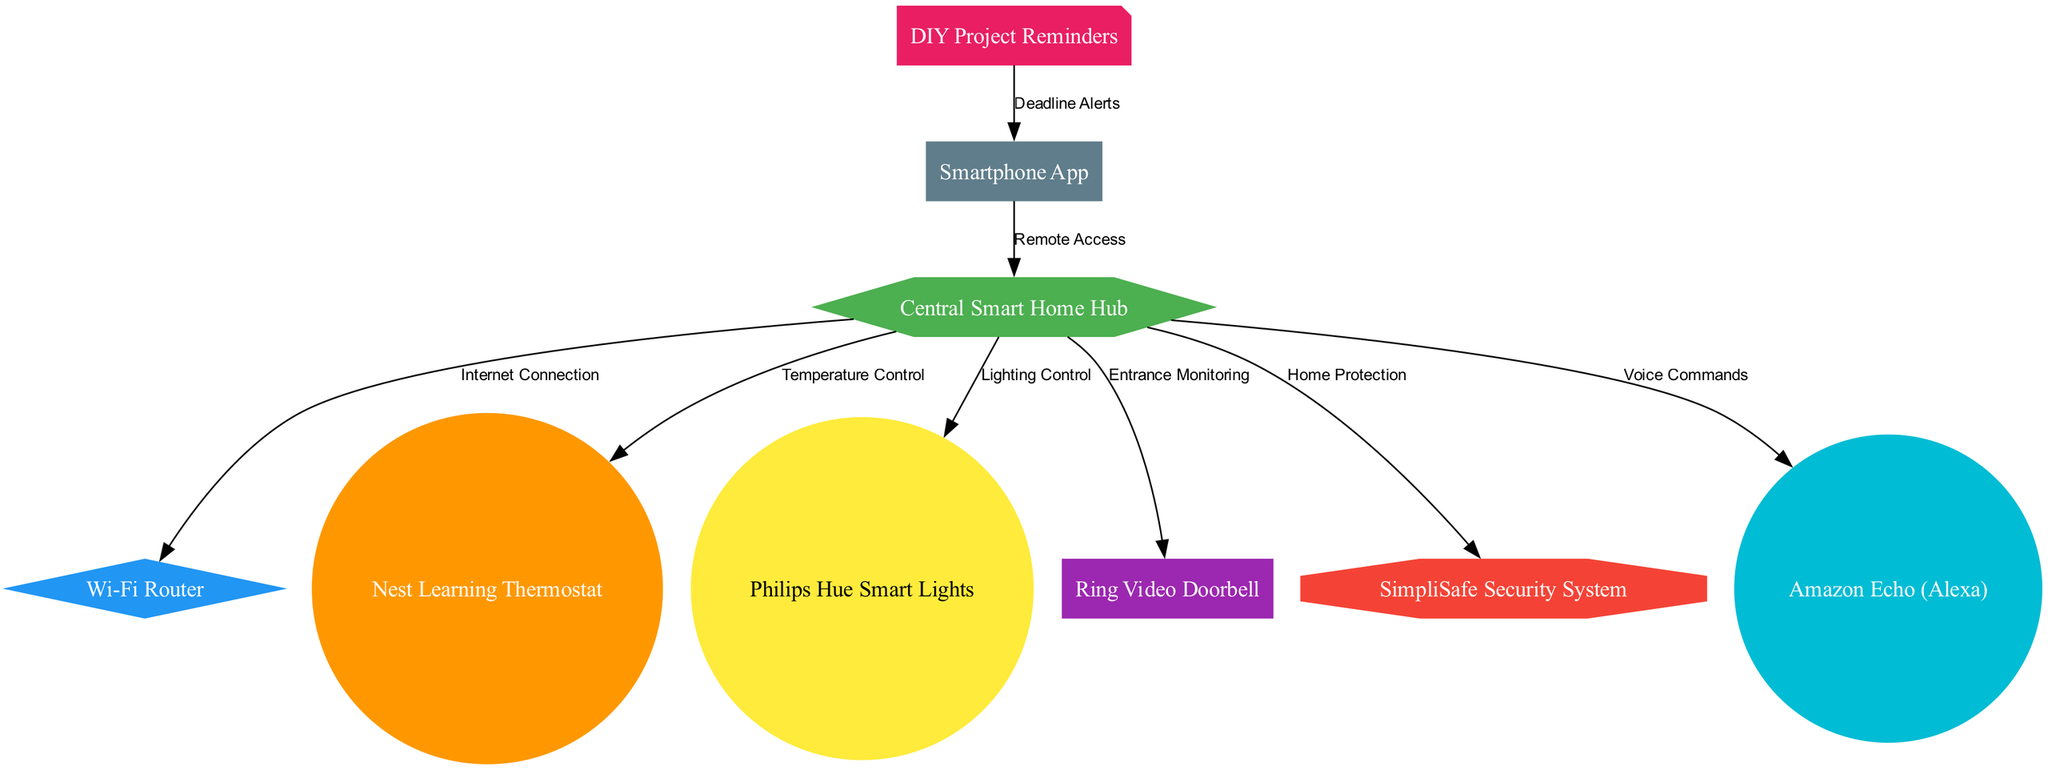What is the central component of the smart home network? The diagram identifies the "Central Smart Home Hub" as the node labeled 'hub', which is the focal point connecting various devices.
Answer: Central Smart Home Hub How many devices are connected to the hub? By counting the edges that lead from the hub node, we find there are six connections, indicating six devices connect to it directly.
Answer: 6 What type of control does the hub provide to the lights? The hub has a connection labeled "Lighting Control" to the node representing the Philips Hue Smart Lights, indicating the type of control it exerts.
Answer: Lighting Control Which device allows for remote access to the network? The diagram shows an edge connecting the node labeled "Smartphone App" to the hub, designated "Remote Access", indicating that the smartphone app facilitates this function.
Answer: Smartphone App What alerts does the phone receive related to DIY projects? The connection labeled "Deadline Alerts" from the "DIY Project Reminders" node to the "Smartphone App" node indicates that alerts specifically related to DIY project deadlines are sent to the smartphone.
Answer: Deadline Alerts How is the home secured according to the diagram? The "SimpliSafe Security System" node connects to the hub with an edge labeled "Home Protection", denoting how the smart home is protected as shown in the diagram.
Answer: Home Protection Which device is responsible for monitoring the entrance? The "Ring Video Doorbell" node directly connects to the hub with an edge labeled "Entrance Monitoring", indicating its role in monitoring entry points of the home.
Answer: Ring Video Doorbell What is the relationship between the hub and the thermostat? The hub and the "Nest Learning Thermostat" are connected with an edge labeled "Temperature Control", denoting the relationship and function within the smart home system.
Answer: Temperature Control How many different types of nodes are present in the diagram? By analyzing the types of nodes listed, there are eight different nodes identified, representing various components in the smart home system.
Answer: 8 